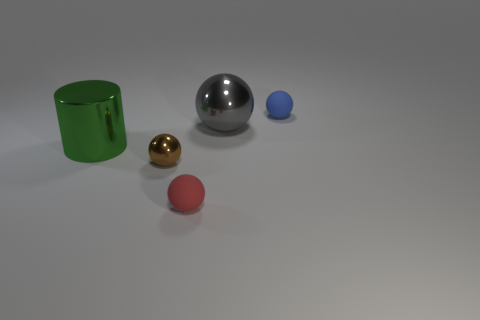There is a metallic sphere to the left of the small red thing; are there any things that are to the left of it?
Give a very brief answer. Yes. Are there any tiny cyan matte blocks?
Offer a very short reply. No. How many other objects are the same size as the brown thing?
Ensure brevity in your answer.  2. How many things are on the left side of the small blue sphere and on the right side of the metal cylinder?
Keep it short and to the point. 3. There is a metallic ball that is in front of the metallic cylinder; does it have the same size as the blue object?
Your response must be concise. Yes. There is a red thing that is made of the same material as the tiny blue sphere; what size is it?
Provide a succinct answer. Small. Is the number of matte things that are on the left side of the blue thing greater than the number of blue matte objects left of the large gray thing?
Offer a very short reply. Yes. How many other things are there of the same material as the brown ball?
Your answer should be compact. 2. Do the large thing that is right of the brown metallic ball and the tiny brown ball have the same material?
Your answer should be compact. Yes. What is the shape of the green object?
Ensure brevity in your answer.  Cylinder. 